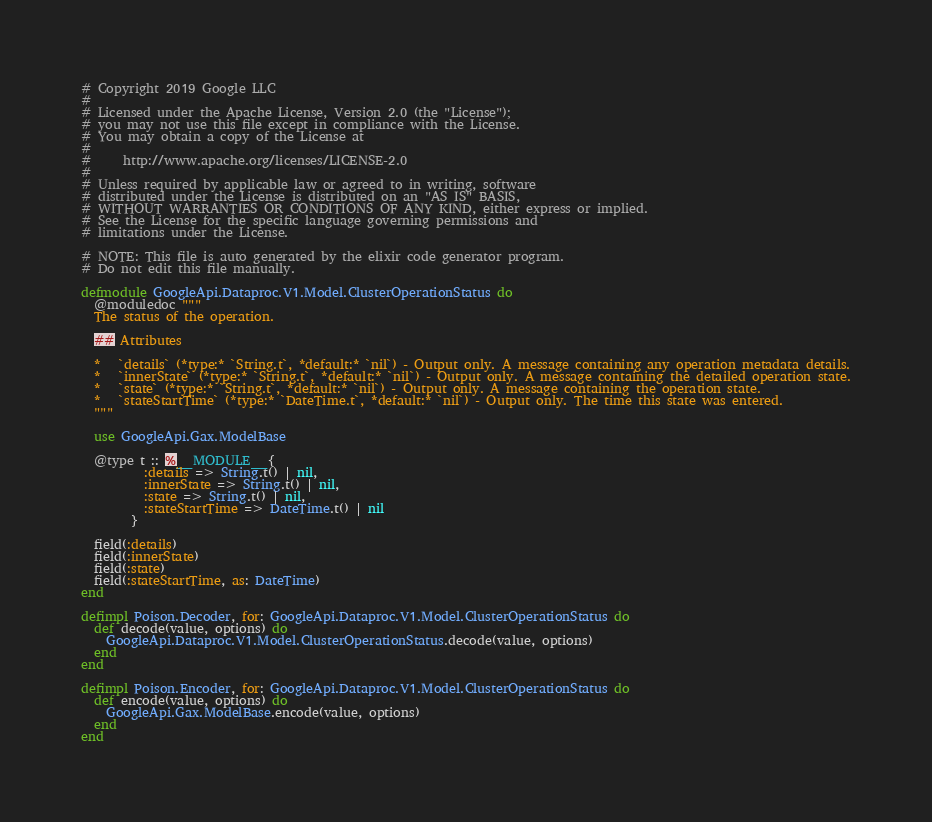<code> <loc_0><loc_0><loc_500><loc_500><_Elixir_># Copyright 2019 Google LLC
#
# Licensed under the Apache License, Version 2.0 (the "License");
# you may not use this file except in compliance with the License.
# You may obtain a copy of the License at
#
#     http://www.apache.org/licenses/LICENSE-2.0
#
# Unless required by applicable law or agreed to in writing, software
# distributed under the License is distributed on an "AS IS" BASIS,
# WITHOUT WARRANTIES OR CONDITIONS OF ANY KIND, either express or implied.
# See the License for the specific language governing permissions and
# limitations under the License.

# NOTE: This file is auto generated by the elixir code generator program.
# Do not edit this file manually.

defmodule GoogleApi.Dataproc.V1.Model.ClusterOperationStatus do
  @moduledoc """
  The status of the operation.

  ## Attributes

  *   `details` (*type:* `String.t`, *default:* `nil`) - Output only. A message containing any operation metadata details.
  *   `innerState` (*type:* `String.t`, *default:* `nil`) - Output only. A message containing the detailed operation state.
  *   `state` (*type:* `String.t`, *default:* `nil`) - Output only. A message containing the operation state.
  *   `stateStartTime` (*type:* `DateTime.t`, *default:* `nil`) - Output only. The time this state was entered.
  """

  use GoogleApi.Gax.ModelBase

  @type t :: %__MODULE__{
          :details => String.t() | nil,
          :innerState => String.t() | nil,
          :state => String.t() | nil,
          :stateStartTime => DateTime.t() | nil
        }

  field(:details)
  field(:innerState)
  field(:state)
  field(:stateStartTime, as: DateTime)
end

defimpl Poison.Decoder, for: GoogleApi.Dataproc.V1.Model.ClusterOperationStatus do
  def decode(value, options) do
    GoogleApi.Dataproc.V1.Model.ClusterOperationStatus.decode(value, options)
  end
end

defimpl Poison.Encoder, for: GoogleApi.Dataproc.V1.Model.ClusterOperationStatus do
  def encode(value, options) do
    GoogleApi.Gax.ModelBase.encode(value, options)
  end
end
</code> 